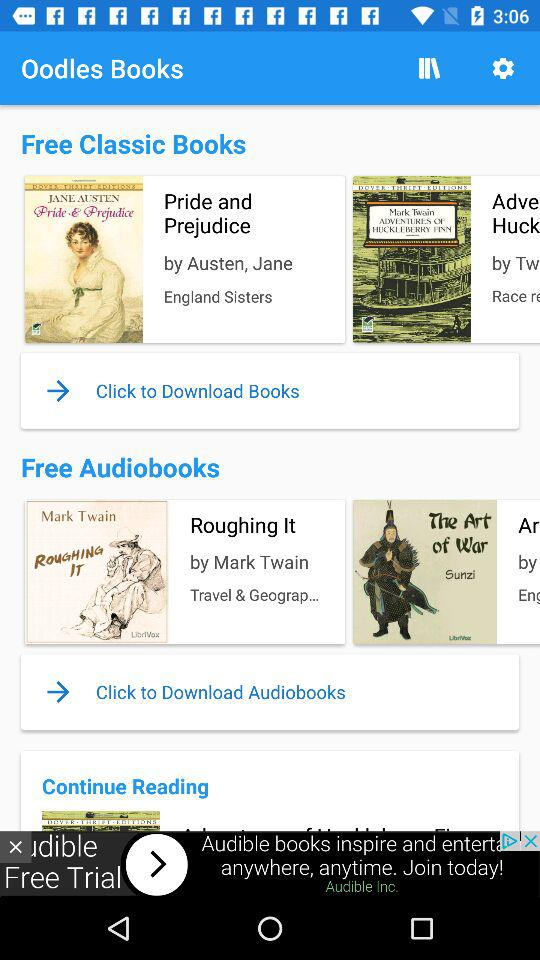What is the name of the application? The name of the application is "Oodles Books". 